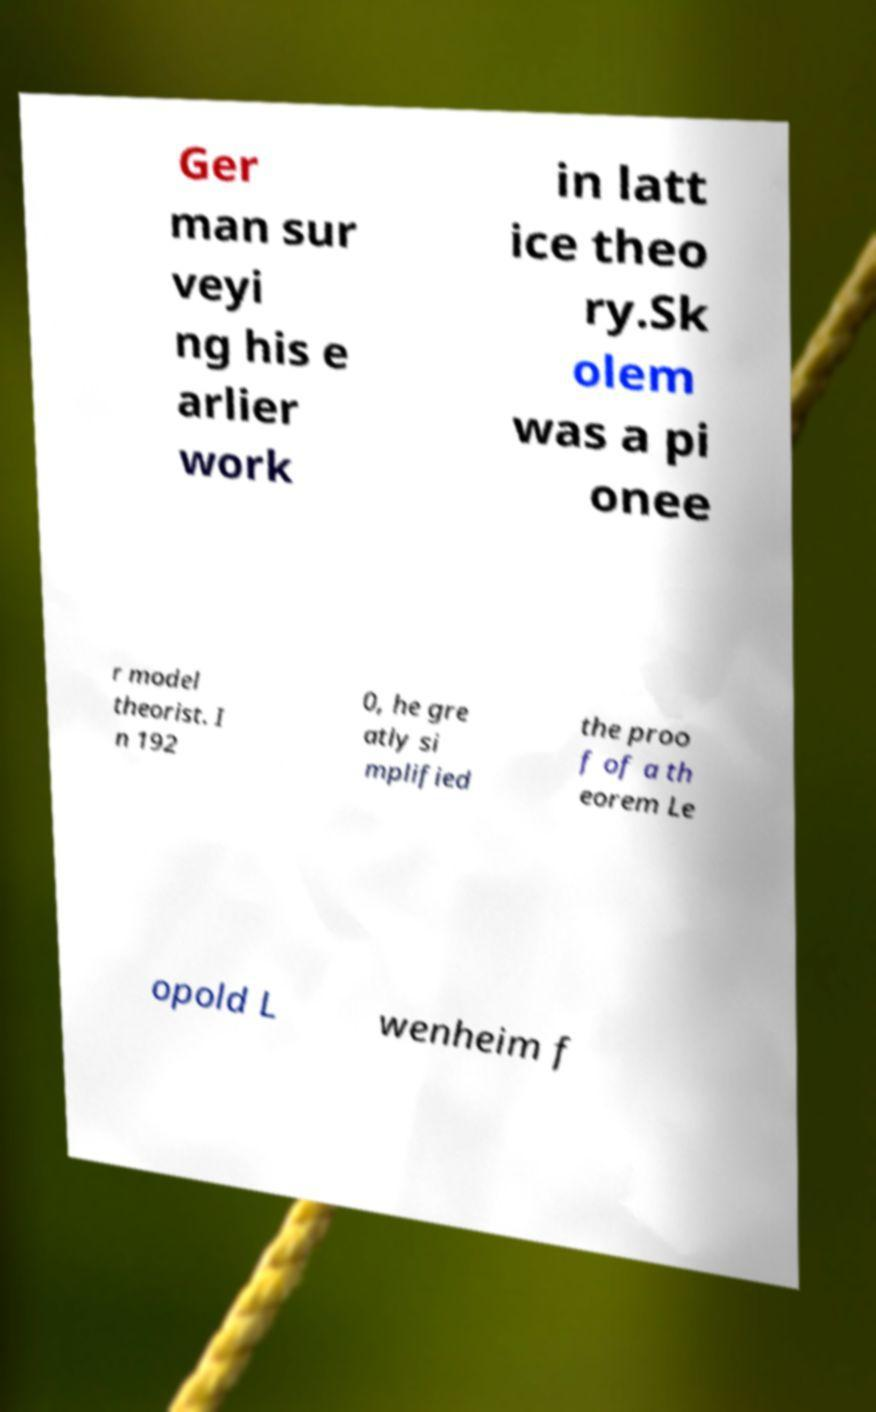For documentation purposes, I need the text within this image transcribed. Could you provide that? Ger man sur veyi ng his e arlier work in latt ice theo ry.Sk olem was a pi onee r model theorist. I n 192 0, he gre atly si mplified the proo f of a th eorem Le opold L wenheim f 